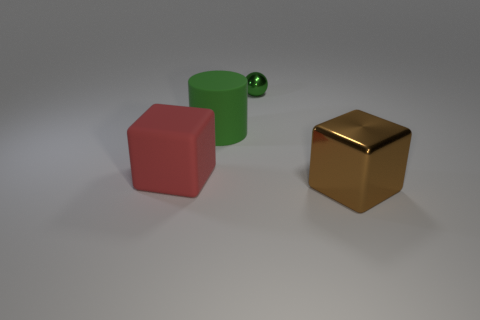There is a block to the right of the red block; is there a big red object that is on the right side of it?
Ensure brevity in your answer.  No. The large rubber thing that is behind the large matte cube has what shape?
Give a very brief answer. Cylinder. There is a sphere that is the same color as the rubber cylinder; what is it made of?
Ensure brevity in your answer.  Metal. What color is the shiny thing to the left of the metal object in front of the green metal sphere?
Make the answer very short. Green. Do the brown metal cube and the green shiny ball have the same size?
Your response must be concise. No. There is another thing that is the same shape as the red thing; what material is it?
Your answer should be compact. Metal. What number of blue rubber blocks have the same size as the brown object?
Your answer should be very brief. 0. The large cube that is the same material as the big cylinder is what color?
Ensure brevity in your answer.  Red. Are there fewer big green rubber objects than blocks?
Provide a short and direct response. Yes. What number of yellow things are either large cubes or tiny metallic things?
Ensure brevity in your answer.  0. 